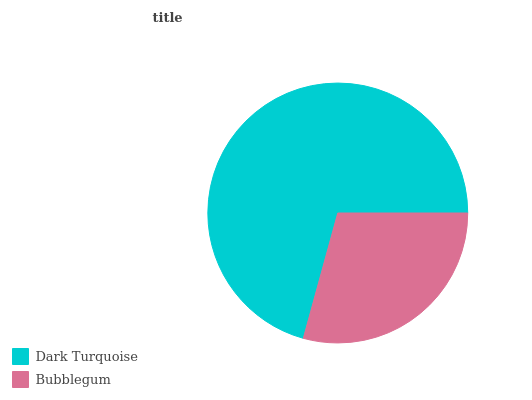Is Bubblegum the minimum?
Answer yes or no. Yes. Is Dark Turquoise the maximum?
Answer yes or no. Yes. Is Bubblegum the maximum?
Answer yes or no. No. Is Dark Turquoise greater than Bubblegum?
Answer yes or no. Yes. Is Bubblegum less than Dark Turquoise?
Answer yes or no. Yes. Is Bubblegum greater than Dark Turquoise?
Answer yes or no. No. Is Dark Turquoise less than Bubblegum?
Answer yes or no. No. Is Dark Turquoise the high median?
Answer yes or no. Yes. Is Bubblegum the low median?
Answer yes or no. Yes. Is Bubblegum the high median?
Answer yes or no. No. Is Dark Turquoise the low median?
Answer yes or no. No. 